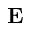Convert formula to latex. <formula><loc_0><loc_0><loc_500><loc_500>E</formula> 